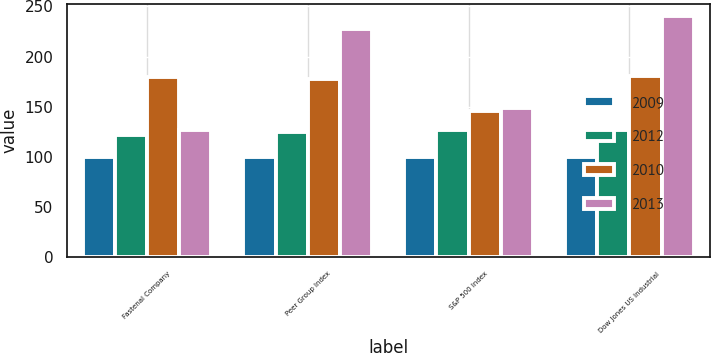Convert chart to OTSL. <chart><loc_0><loc_0><loc_500><loc_500><stacked_bar_chart><ecel><fcel>Fastenal Company<fcel>Peer Group Index<fcel>S&P 500 Index<fcel>Dow Jones US Industrial<nl><fcel>2009<fcel>100<fcel>100<fcel>100<fcel>100<nl><fcel>2012<fcel>121.93<fcel>125.31<fcel>126.46<fcel>127.17<nl><fcel>2010<fcel>180.07<fcel>177.17<fcel>145.51<fcel>180.7<nl><fcel>2013<fcel>127.17<fcel>227.82<fcel>148.59<fcel>240.29<nl></chart> 